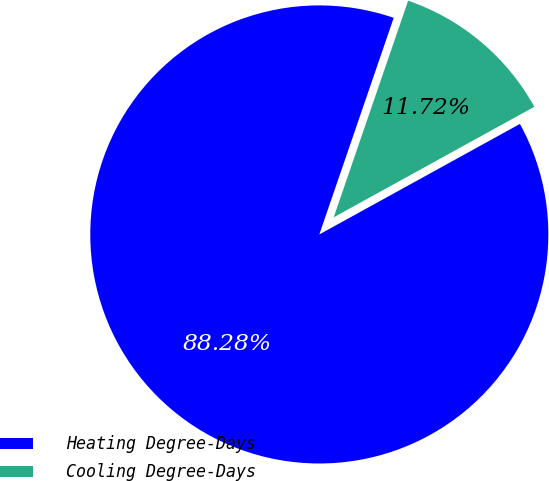<chart> <loc_0><loc_0><loc_500><loc_500><pie_chart><fcel>Heating Degree-Days<fcel>Cooling Degree-Days<nl><fcel>88.28%<fcel>11.72%<nl></chart> 